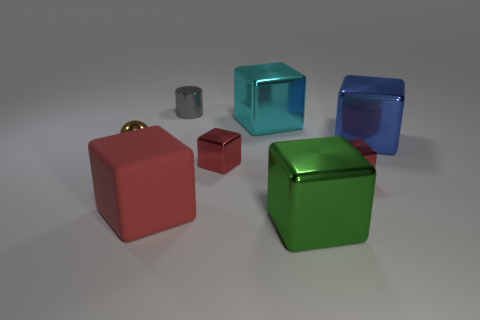Is the small brown sphere made of the same material as the big red block?
Your answer should be compact. No. Do the tiny gray metal thing and the shiny object to the left of the rubber cube have the same shape?
Offer a very short reply. No. There is a green shiny object to the left of the big blue thing; is its shape the same as the small gray metal thing?
Your answer should be very brief. No. Is there anything else that is the same shape as the cyan thing?
Your answer should be very brief. Yes. What number of cylinders are either large red rubber things or tiny gray metallic things?
Give a very brief answer. 1. What number of tiny red objects are there?
Your answer should be very brief. 2. What is the size of the shiny thing that is right of the red metal block that is to the right of the big green thing?
Provide a succinct answer. Large. How many other things are the same size as the blue metal cube?
Ensure brevity in your answer.  3. There is a blue metallic thing; what number of large things are in front of it?
Ensure brevity in your answer.  2. The cyan object has what size?
Provide a succinct answer. Large. 